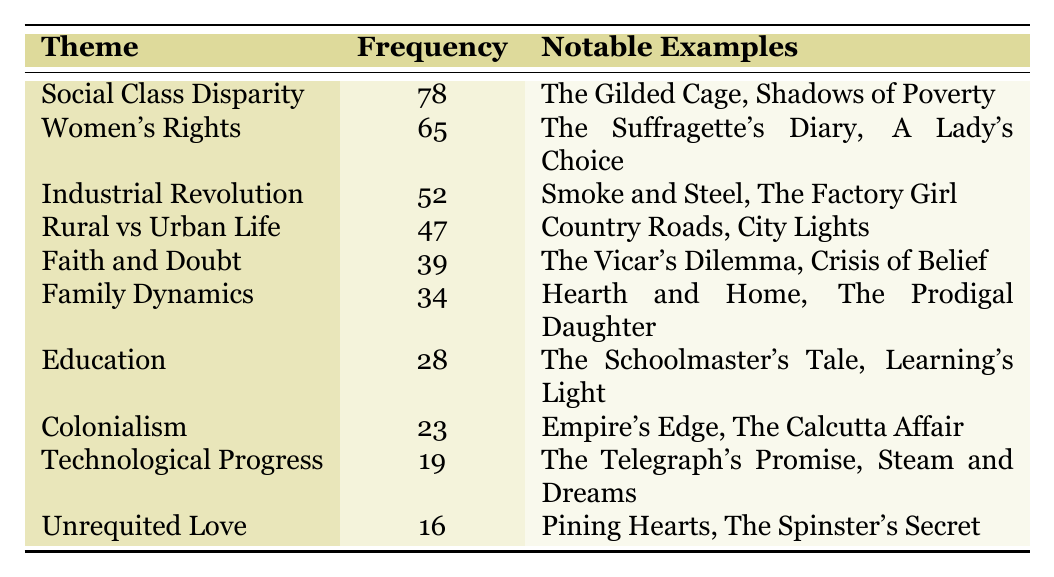What is the theme with the highest frequency in Hope Hawkins' works? The table indicates that "Social Class Disparity" has the highest frequency of 78.
Answer: Social Class Disparity How many themes have a frequency of 50 or more? By counting the themes listed in the table, "Social Class Disparity," "Women's Rights," and "Industrial Revolution" have frequencies of 78, 65, and 52, respectively, totaling 3 themes.
Answer: 3 What notable example is associated with the theme of Colonialism? The table notes that "Empire's Edge" and "The Calcutta Affair" are notable examples related to the theme of Colonialism.
Answer: Empire's Edge, The Calcutta Affair Is there a theme that focuses on both education and family dynamics? The table does not indicate any theme that explicitly combines education and family dynamics, as there are separate entries for "Education" and "Family Dynamics."
Answer: No What is the difference in frequency between the theme of Women’s Rights and the theme of Technological Progress? Calculating the difference: Women's Rights has a frequency of 65 and Technological Progress has a frequency of 19. Therefore, the difference is 65 - 19 = 46.
Answer: 46 If we combine the frequencies of “Faith and Doubt” and “Family Dynamics,” what is the total? Adding the frequencies of both themes: Faith and Doubt is 39 and Family Dynamics is 34, so the total is 39 + 34 = 73.
Answer: 73 Which theme has the least frequency, and what is that frequency? The table shows that "Unrequited Love" has the least frequency at 16.
Answer: Unrequited Love, 16 What fraction of the themes relate to social issues (Social Class Disparity, Women’s Rights, and Family Dynamics)? There are 3 themes related to social issues mentioned in the table, out of a total of 10 themes. Thus, the fraction is 3/10.
Answer: 3/10 Is "Technological Progress" a more prominent theme than "Unrequited Love"? The frequencies show that Technological Progress is 19 while Unrequited Love is 16, meaning Technological Progress is more prominent.
Answer: Yes What is the average frequency of the themes in the table? First, sum all frequencies: 78 + 65 + 52 + 47 + 39 + 34 + 28 + 23 + 19 + 16 = 461. There are 10 themes, so the average is 461 / 10 = 46.1.
Answer: 46.1 